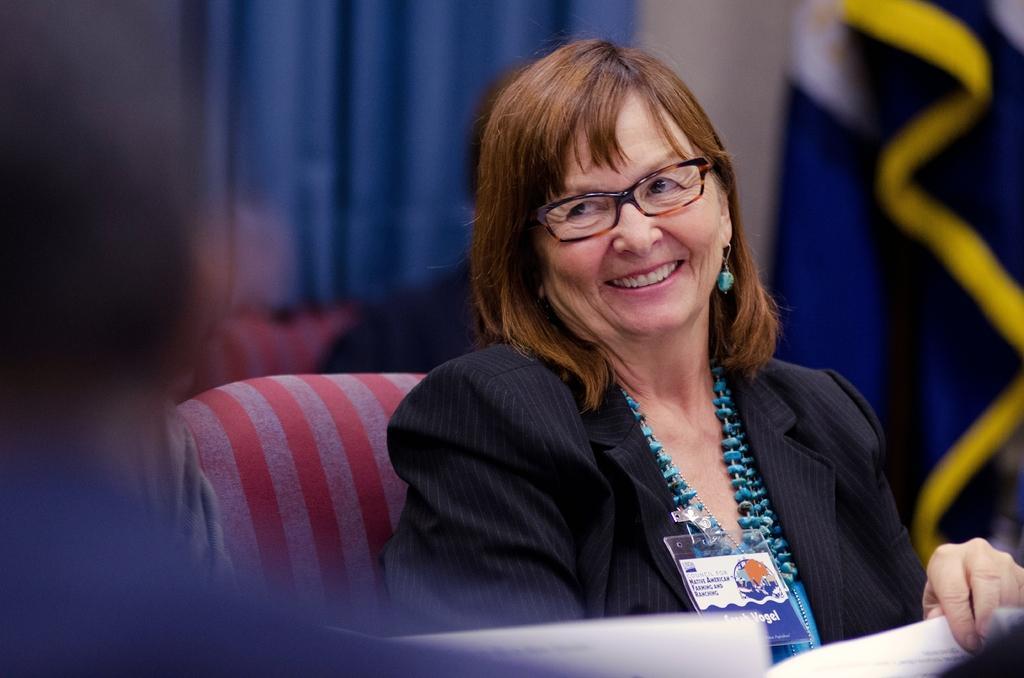In one or two sentences, can you explain what this image depicts? Background portion of the picture is blur. We can see a blue cloth. On the right side of the picture it seems like a flag. In this picture we can see a woman sitting on a chair, wearing blue color jewellery, spectacles and she is smiling. At the bottom portion of the picture we can see the papers. 